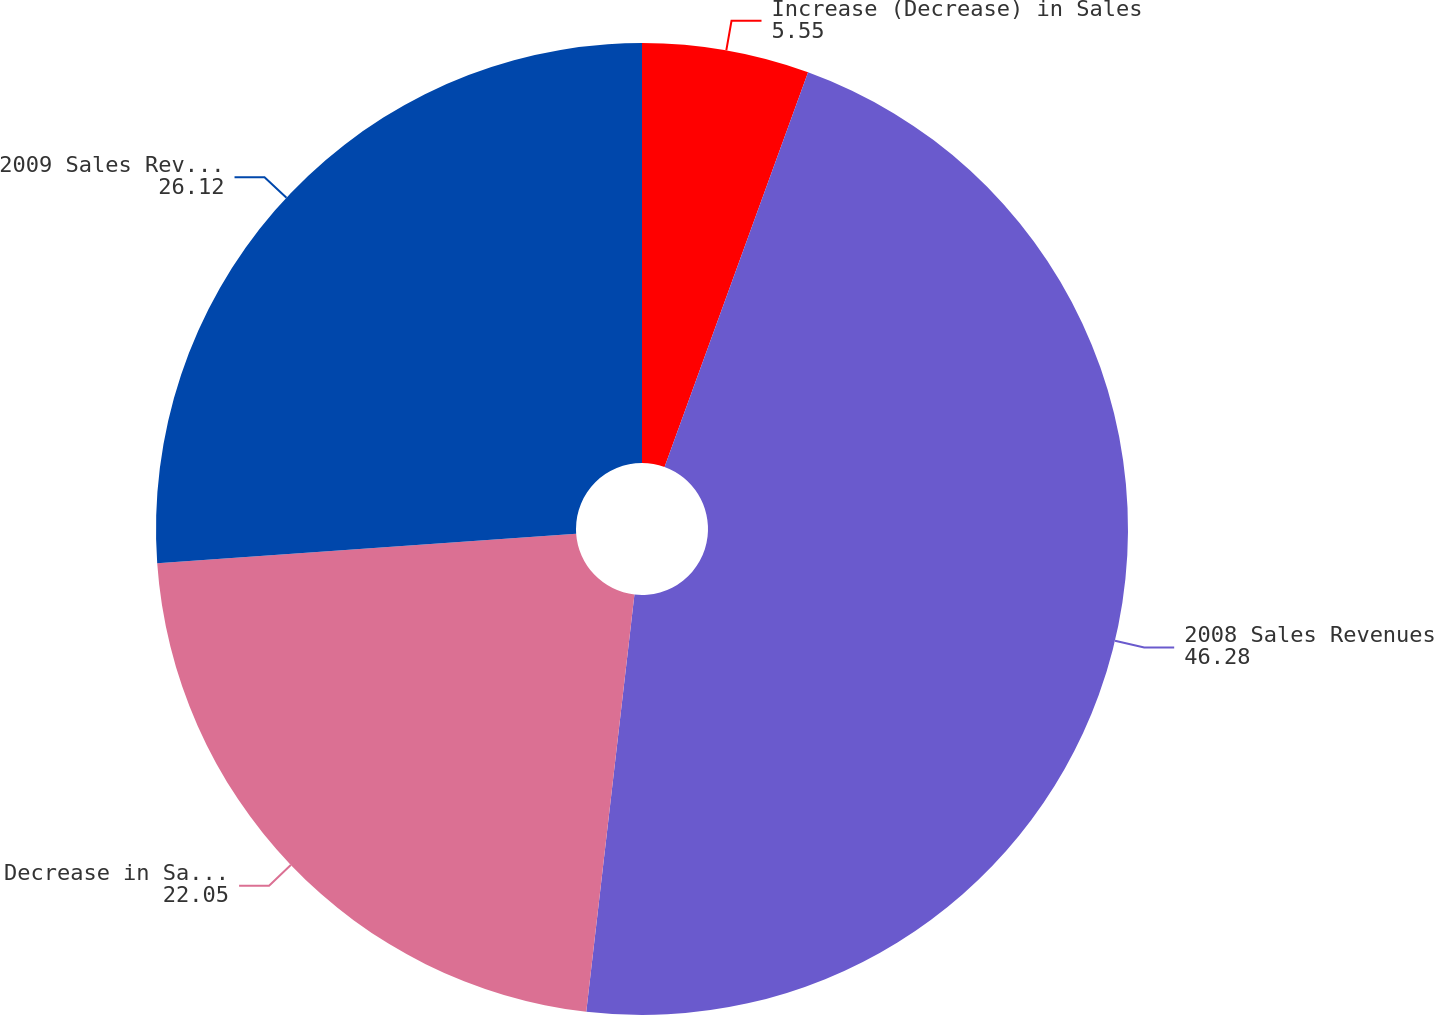Convert chart to OTSL. <chart><loc_0><loc_0><loc_500><loc_500><pie_chart><fcel>Increase (Decrease) in Sales<fcel>2008 Sales Revenues<fcel>Decrease in Sales Prices<fcel>2009 Sales Revenues<nl><fcel>5.55%<fcel>46.28%<fcel>22.05%<fcel>26.12%<nl></chart> 